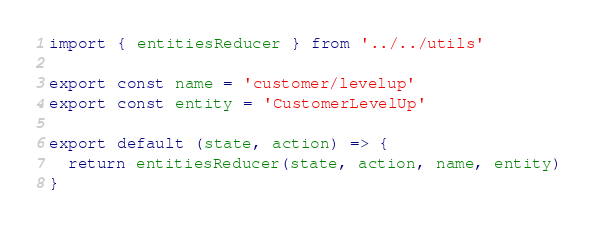Convert code to text. <code><loc_0><loc_0><loc_500><loc_500><_JavaScript_>import { entitiesReducer } from '../../utils'

export const name = 'customer/levelup'
export const entity = 'CustomerLevelUp'

export default (state, action) => {
  return entitiesReducer(state, action, name, entity)
}
</code> 